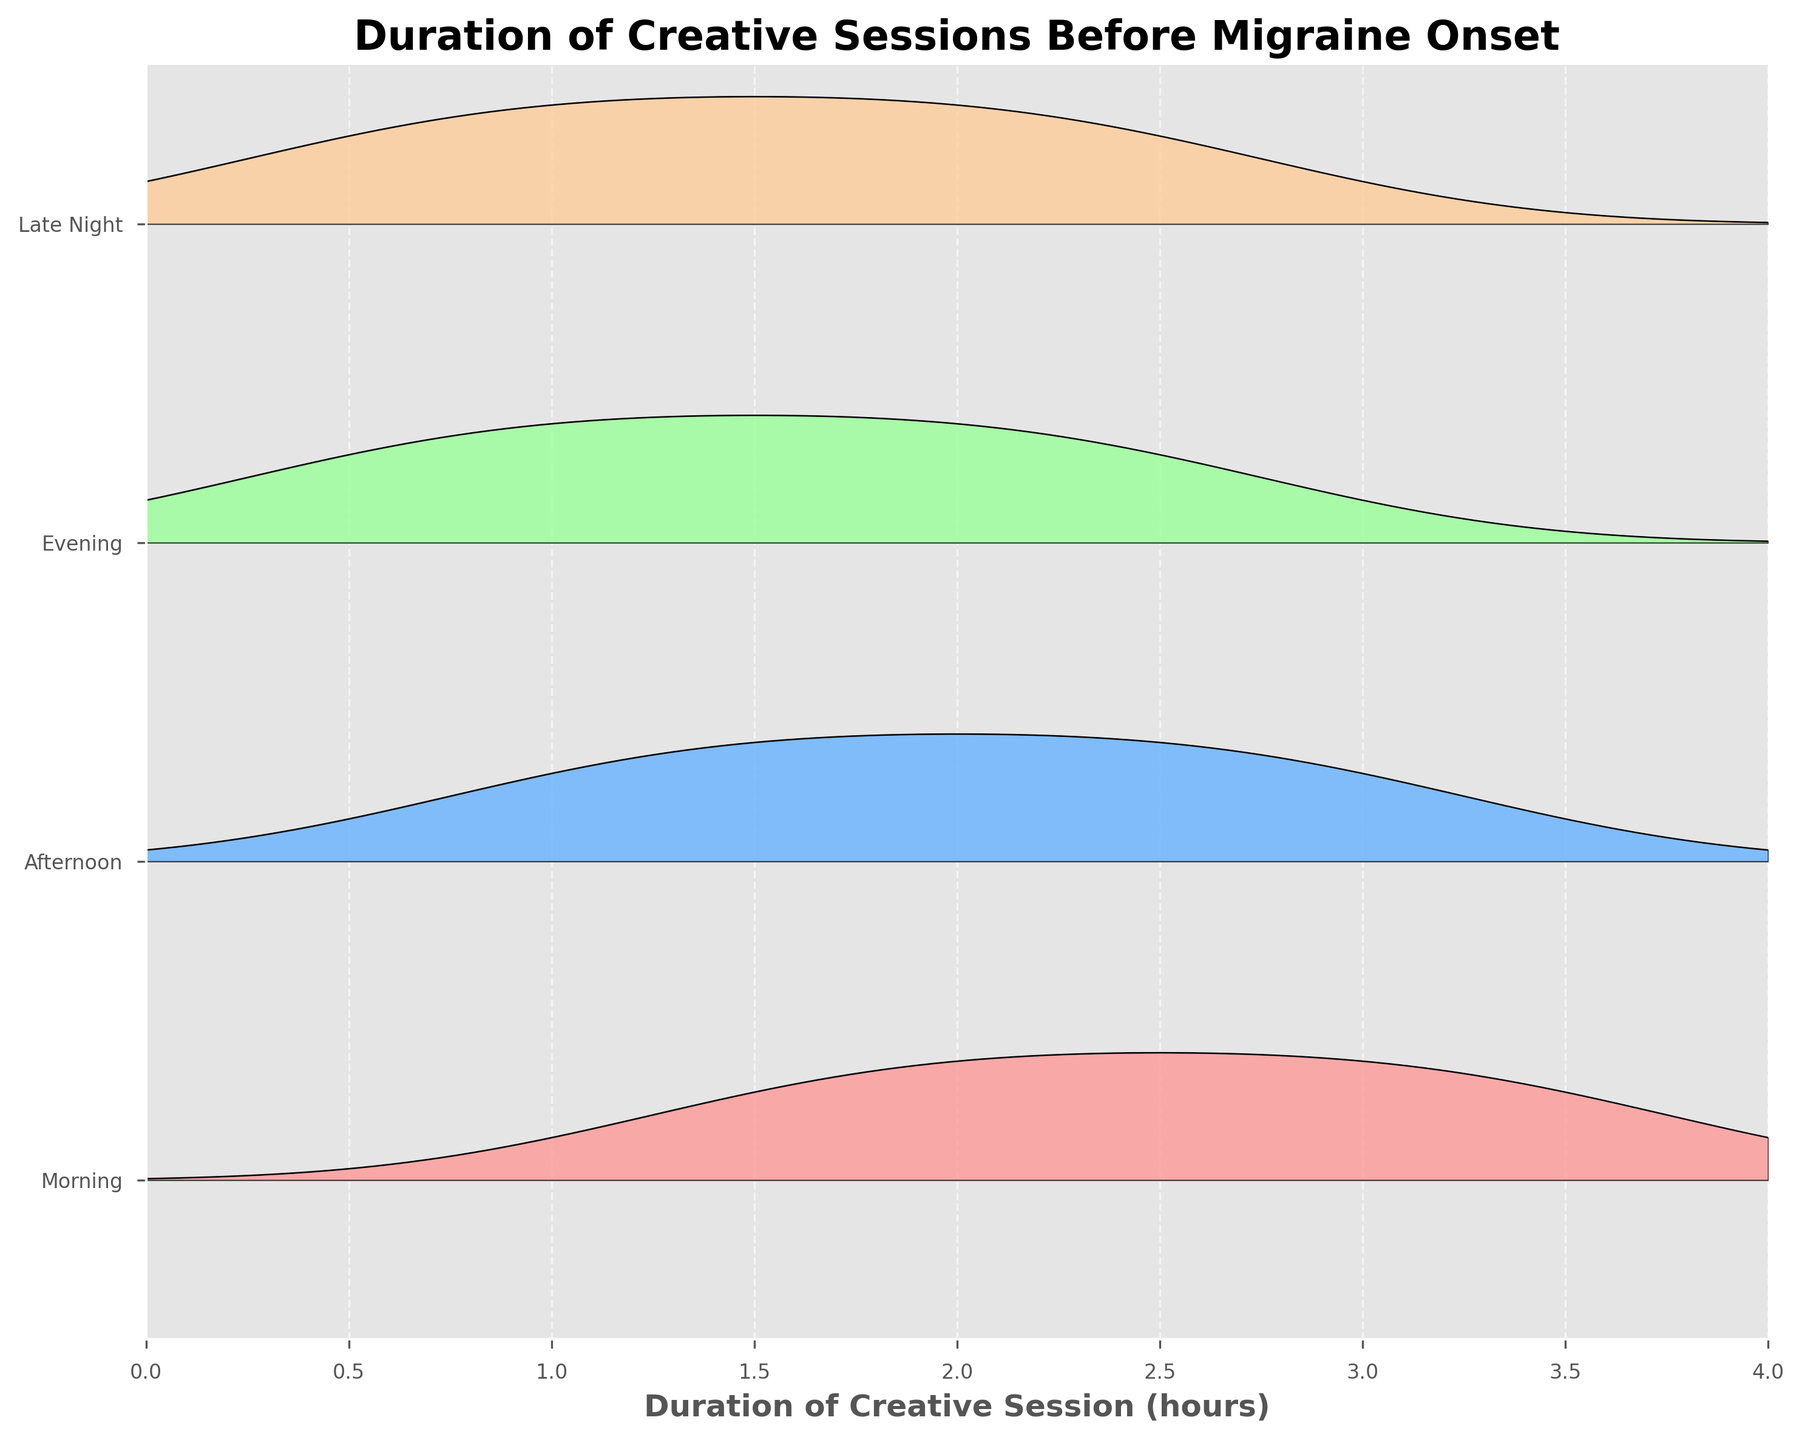How many different time periods are represented in the plot? The y-axis has labels for each time period. By counting these labels, we see Morning, Afternoon, Evening, and Late Night.
Answer: 4 What is the title of the figure? The title of the figure is located at the top of the plot.
Answer: Duration of Creative Sessions Before Migraine Onset Which time period has the shortest duration before a migraine onset? Identify the peak closest to the y-axis, indicating shorter durations. The Evening time period has a lower peak compared to others.
Answer: Evening Which time period has the widest distribution of session durations? Compare the spread of each colored area along the x-axis. The Morning time period covers the widest range from 1.5 to around 3.5 hours.
Answer: Morning What is the x-axis label of the plot? The x-axis label provides information about the horizontal dimension of the plot and is found just below the x-axis.
Answer: Duration of Creative Session (hours) Which time period generally has the longest duration before a migraine onset? Identify the time period whose distribution peaks at a higher x-axis value. The Morning period peaks further to the right.
Answer: Morning What is the average duration of creative sessions in the Evening period? The peak of the distribution reflects the mode, and the range center can approximate the average. Evening peaks around 1.25 hours.
Answer: 1.25 hours How does the Late Night period's peak compare to the Morning period's peak? Compare the x-axis position of the peaks for both time periods. The Morning period peaks further right than the Late Night period, indicating longer durations.
Answer: Late Night is shorter Is there any overlap in the durations between different time periods? Visually check if the filled areas for different time periods overlap along the x-axis. There are overlaps, for example, between Afternoon and Morning around 2.5 hours.
Answer: Yes Which time period has the smallest variability in session durations? Determine the narrowest spread of filled area along the x-axis. The Evening period has the smallest spread.
Answer: Evening 